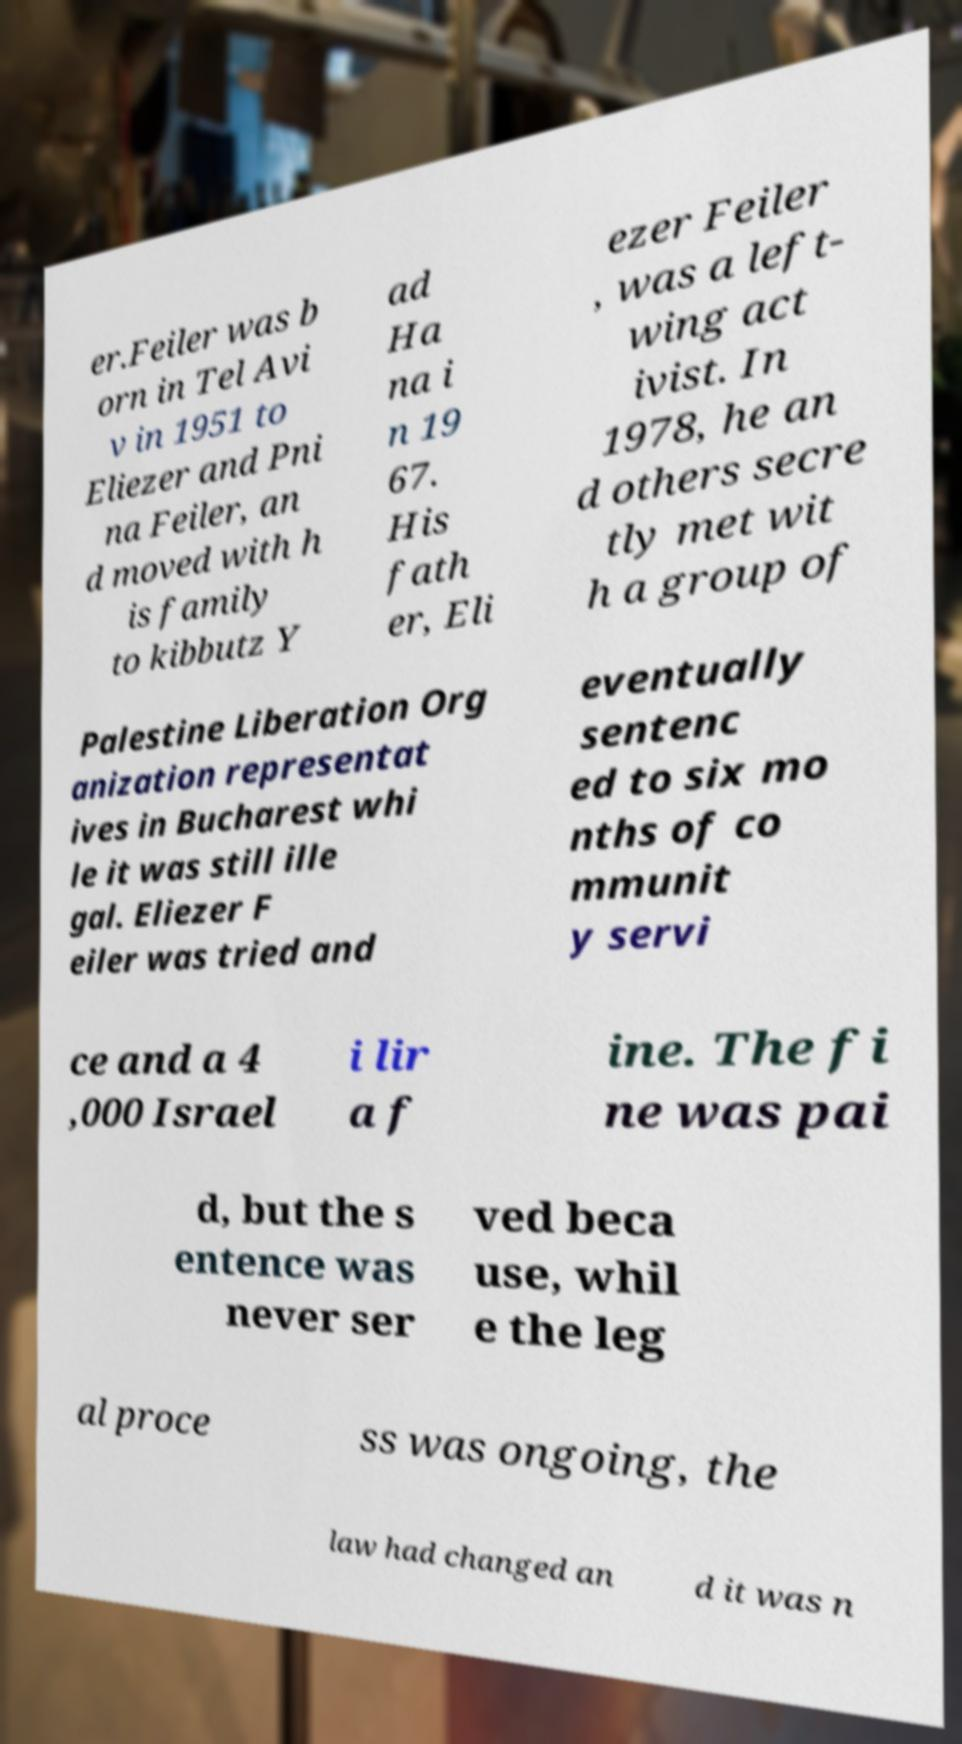Can you read and provide the text displayed in the image?This photo seems to have some interesting text. Can you extract and type it out for me? er.Feiler was b orn in Tel Avi v in 1951 to Eliezer and Pni na Feiler, an d moved with h is family to kibbutz Y ad Ha na i n 19 67. His fath er, Eli ezer Feiler , was a left- wing act ivist. In 1978, he an d others secre tly met wit h a group of Palestine Liberation Org anization representat ives in Bucharest whi le it was still ille gal. Eliezer F eiler was tried and eventually sentenc ed to six mo nths of co mmunit y servi ce and a 4 ,000 Israel i lir a f ine. The fi ne was pai d, but the s entence was never ser ved beca use, whil e the leg al proce ss was ongoing, the law had changed an d it was n 